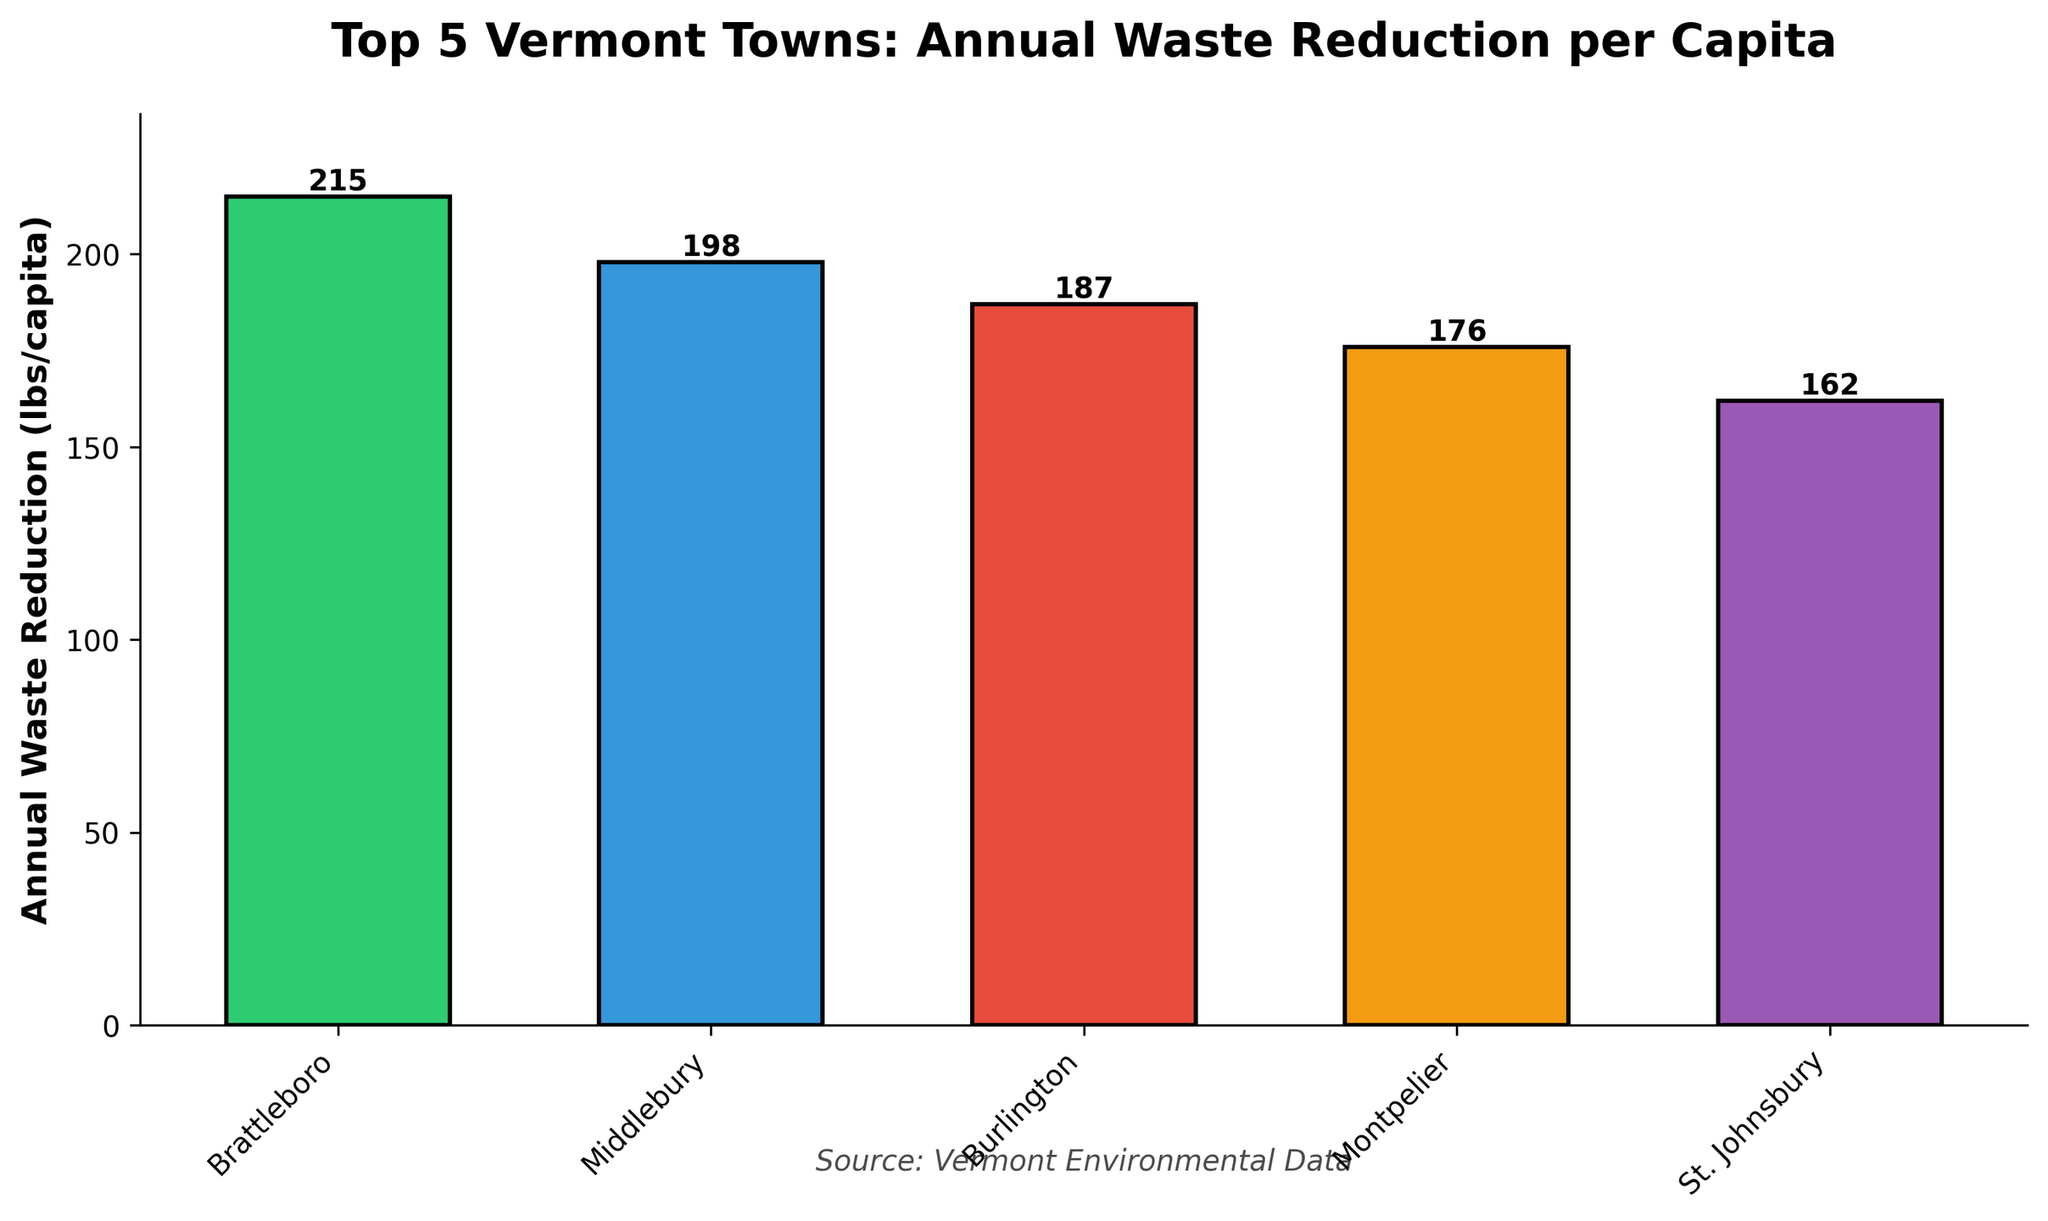Which town has the highest annual waste reduction per capita? By observing the height of the bars, Brattleboro has the tallest bar, indicating the highest waste reduction.
Answer: Brattleboro What's the difference in annual waste reduction per capita between Brattleboro and St. Johnsbury? Brattleboro has 215 lbs/capita, and St. Johnsbury has 162 lbs/capita. Subtracting 162 from 215 gives 53.
Answer: 53 lbs/capita How much higher is Middlebury's waste reduction per capita compared to Burlington's? Middlebury has 198 lbs/capita, and Burlington has 187 lbs/capita. Subtracting 187 from 198 gives 11.
Answer: 11 lbs/capita Which towns have a waste reduction per capita of more than 190 lbs? Brattleboro has 215 lbs/capita and Middlebury has 198 lbs/capita; both values are greater than 190.
Answer: Brattleboro, Middlebury What is the average waste reduction per capita of the top 5 towns? Sum of 215 (Brattleboro), 198 (Middlebury), 187 (Burlington), 176 (Montpelier), and 162 (St. Johnsbury) is 938. Dividing by 5 gives 187.6.
Answer: 187.6 lbs/capita What is the color associated with Montpelier's bar? Observing the visual attributes, Montpelier's bar is colored orange.
Answer: orange What is the total annual waste reduction per capita for the top 3 towns combined? Sum of 215 (Brattleboro), 198 (Middlebury), and 187 (Burlington) is 600.
Answer: 600 lbs/capita How much lower is St. Johnsbury's waste reduction per capita compared to Montpelier's? Montpelier has 176 lbs/capita, and St. Johnsbury has 162 lbs/capita. Subtracting 162 from 176 gives 14.
Answer: 14 lbs/capita Which town's bar is colored green? Observing the visual attributes, Brattleboro's bar is colored green.
Answer: Brattleboro 